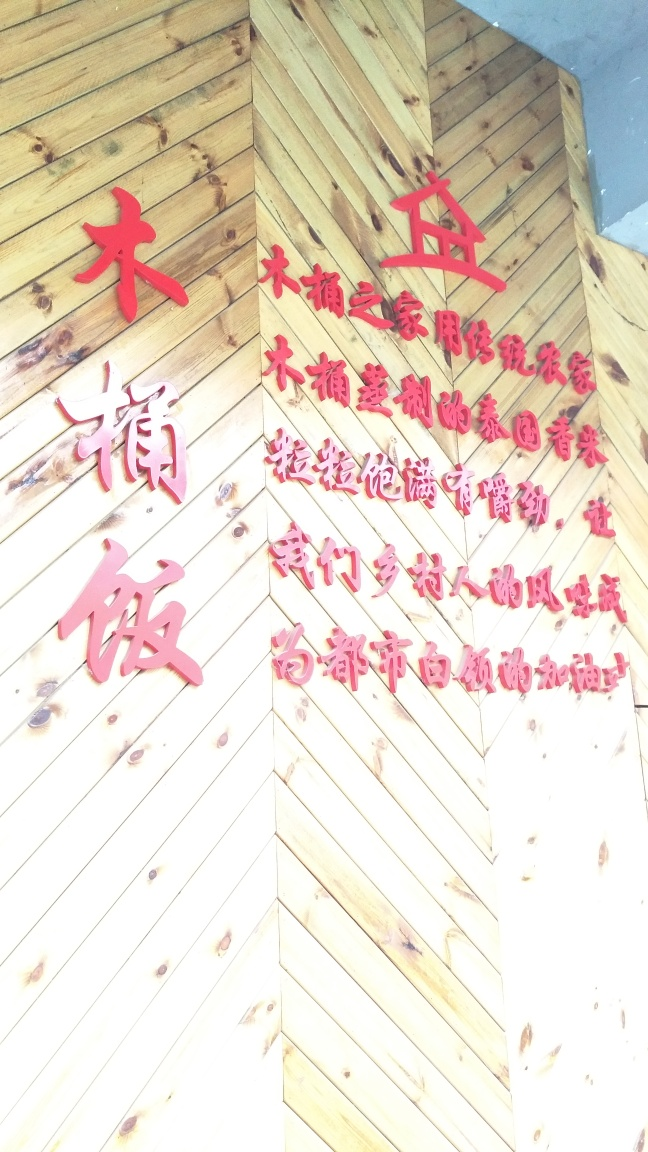Do the colors in the image have any particular meaning? In Chinese culture, red is often associated with good fortune, happiness, and prosperity, which is why it's prominently used during festivals, weddings, and other important occasions. The red characters against the wooden background may be emphasizing these aspects of luck and joy. Is there any significance to the design pattern of the wooden backdrop? The angled wooden planks create a dynamic and textured background, which could be intentional to draw more attention to the characters, or it might simply be a stylistic choice that gives the setting a more traditional or naturalistic appeal. 